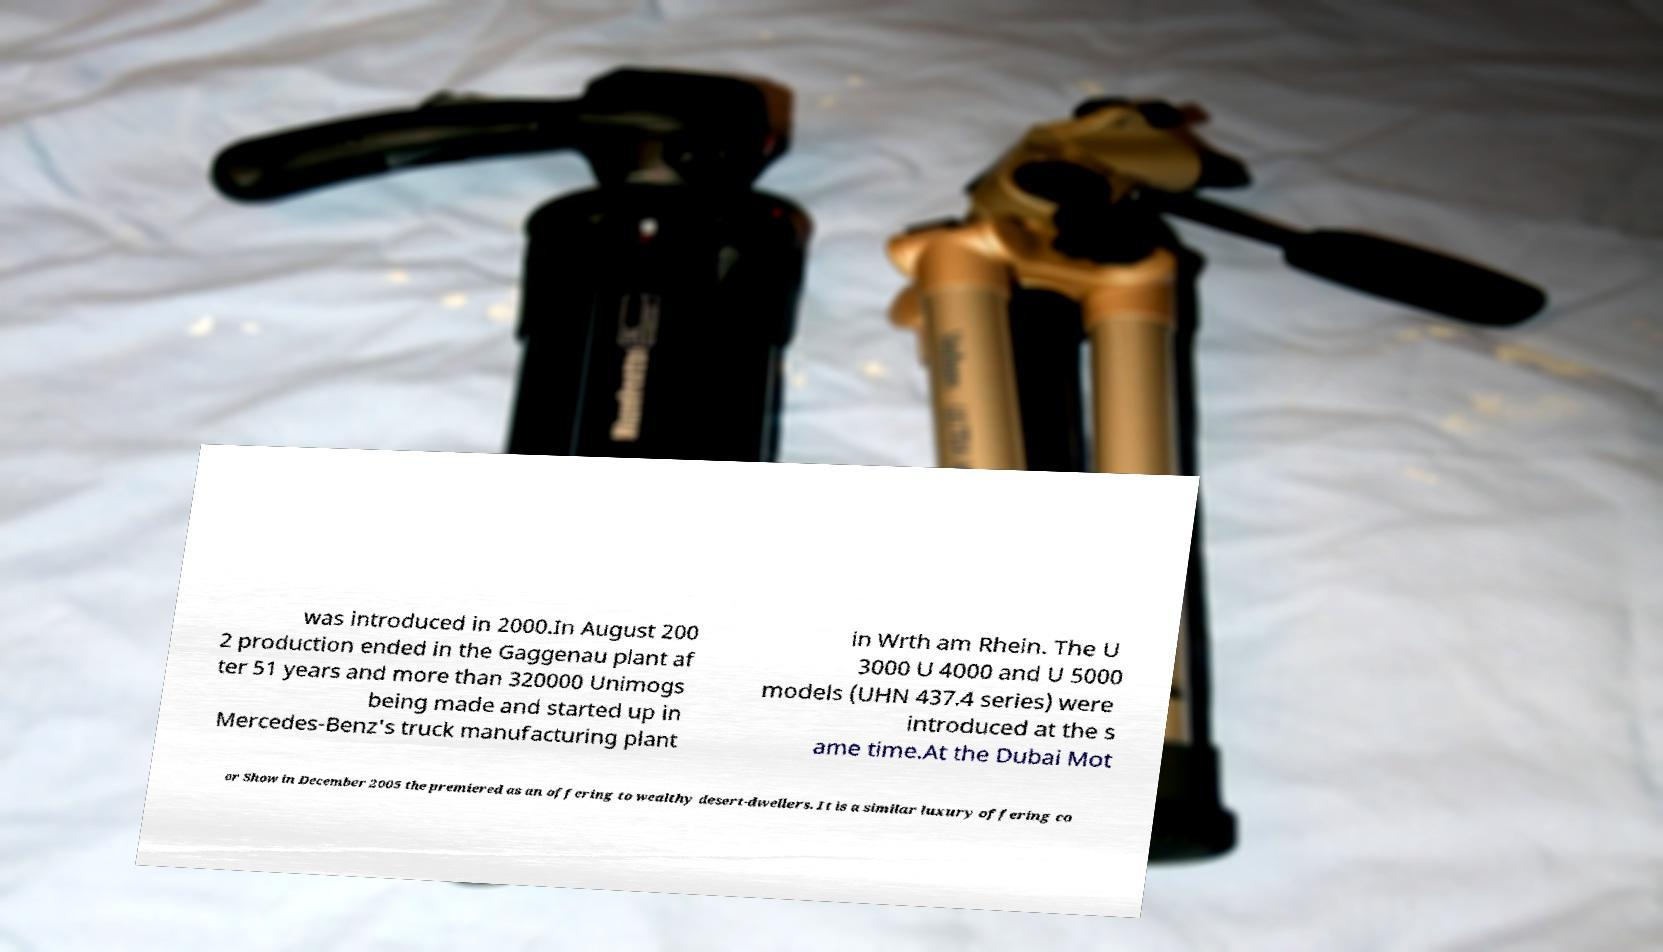Can you accurately transcribe the text from the provided image for me? was introduced in 2000.In August 200 2 production ended in the Gaggenau plant af ter 51 years and more than 320000 Unimogs being made and started up in Mercedes-Benz's truck manufacturing plant in Wrth am Rhein. The U 3000 U 4000 and U 5000 models (UHN 437.4 series) were introduced at the s ame time.At the Dubai Mot or Show in December 2005 the premiered as an offering to wealthy desert-dwellers. It is a similar luxury offering co 